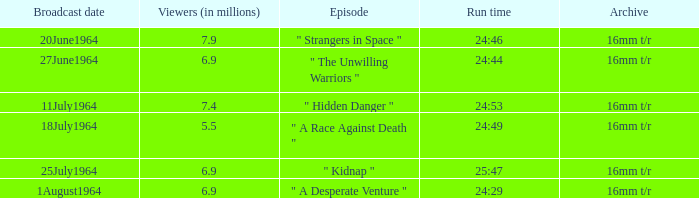What is run time when there were 7.4 million viewers? 24:53. 